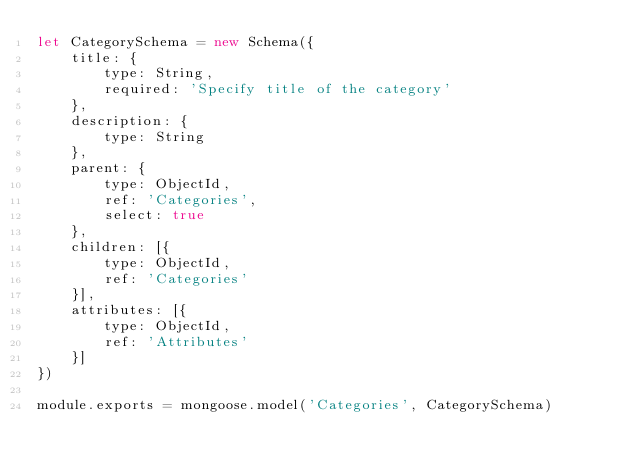Convert code to text. <code><loc_0><loc_0><loc_500><loc_500><_JavaScript_>let CategorySchema = new Schema({
	title: {
		type: String,
		required: 'Specify title of the category'
	},
	description: {
		type: String
	},
	parent: {
		type: ObjectId,
		ref: 'Categories',
		select: true
	},
	children: [{
		type: ObjectId,
		ref: 'Categories'
	}],
	attributes: [{
		type: ObjectId,
		ref: 'Attributes'
	}]
})

module.exports = mongoose.model('Categories', CategorySchema)
</code> 